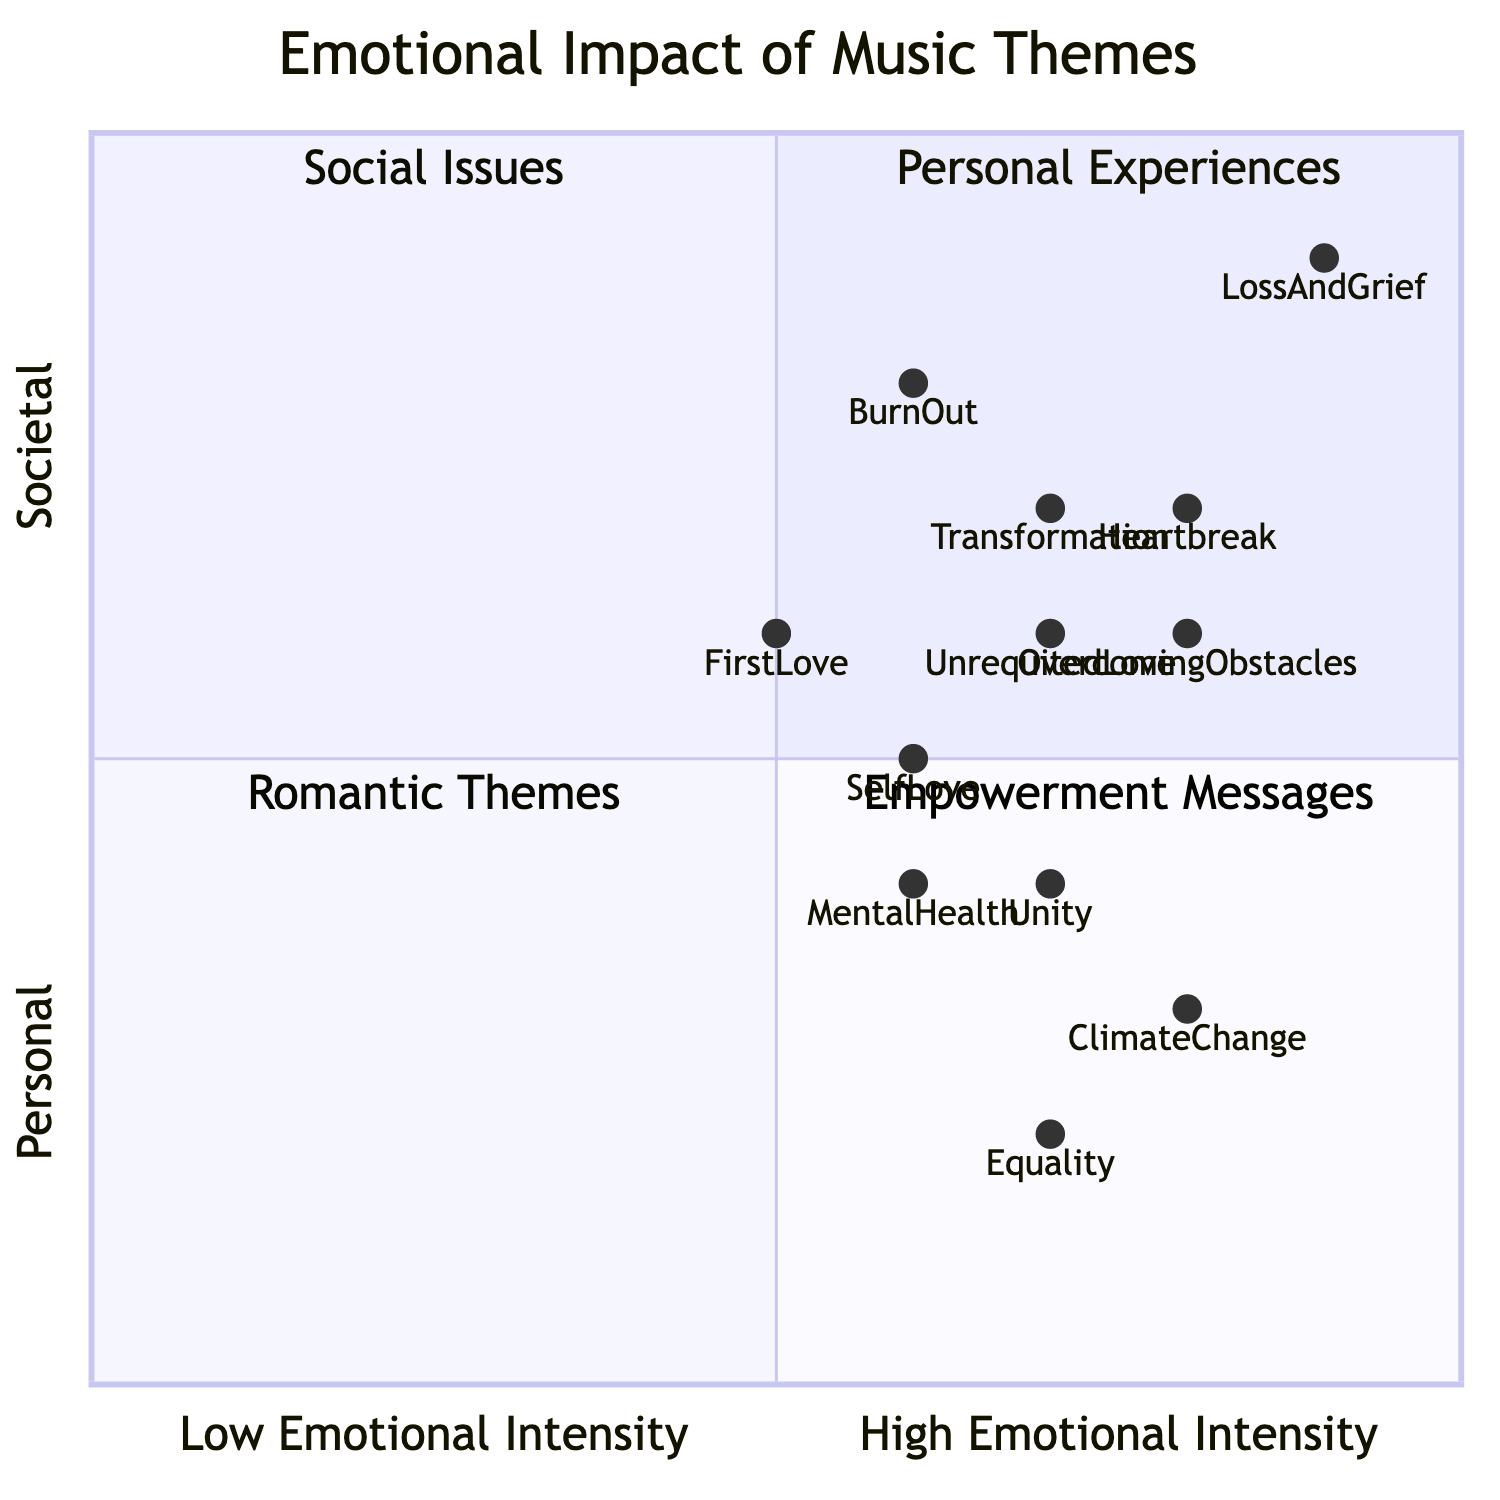What is the emotional intensity of the song "LossAndGrief"? The emotional intensity is represented by the coordinates in the diagram. For "LossAndGrief," the coordinates are [0.9, 0.9], indicating a high emotional intensity near the maximum value on both axes.
Answer: 0.9 Which theme has the lowest emotional intensity? Looking at the quadrant chart, the theme with the lowest emotional intensity in both aspects is "FirstLove," with coordinates [0.5, 0.6], which is the lowest value in the x-axis among themes.
Answer: FirstLove How many songs are categorized under "Empowerment Messages"? The "Empowerment Messages" quadrant contains three songs: "SelfLove," "OvercomingObstacles," and "Unity." Counting these gives us the total number of songs.
Answer: 3 Which theme addresses societal issues and has the highest emotional intensity? By examining the songs in the "Social Issues" quadrant, "ClimateChange" has an emotional intensity of [0.8, 0.3], which is the highest on the y-axis for that category, when compared to the other songs in the same quadrant.
Answer: ClimateChange What is the relationship between "Heartbreak" and "LossAndGrief"? Both themes are located in their respective quadrants and have a high emotional intensity. "Heartbreak" has a coordinate of [0.8, 0.7] in the "Romantic Themes" quadrant, while "LossAndGrief" is at [0.9, 0.9]. Both themes reflect significant emotional impact, but "LossAndGrief" is higher in both personal and emotional intensity.
Answer: LossAndGrief is higher in intensity Which theme related to personal experiences has a higher emotional intensity than "BurnOut"? The themes addressing personal experiences include "BurnOut," "Transformation," and "LossAndGrief." Among these, "Transformation" has a coordinate of [0.7, 0.7], which is higher than "BurnOut," which is [0.6, 0.8]. Therefore, the answer is "Transformation."
Answer: Transformation 